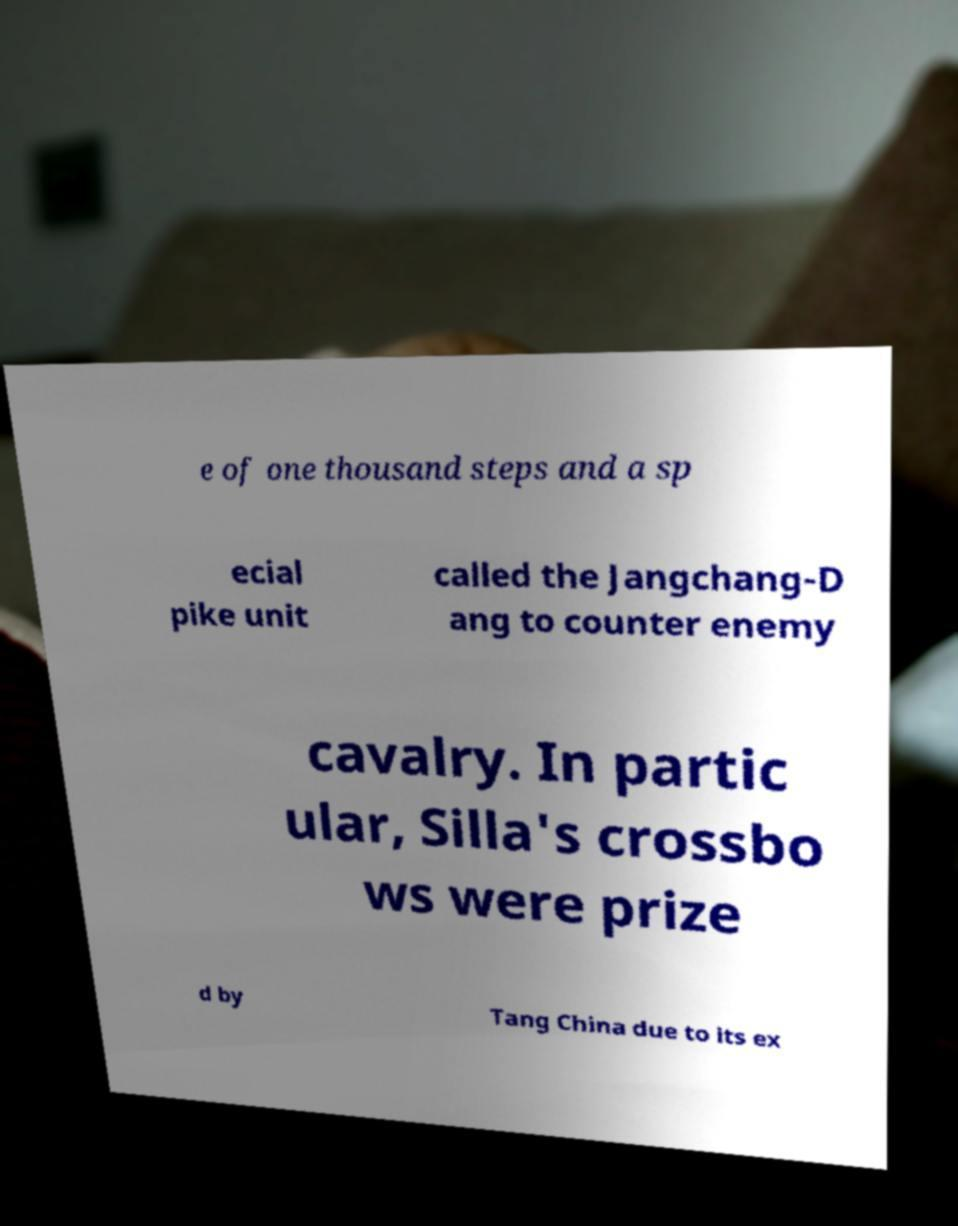What messages or text are displayed in this image? I need them in a readable, typed format. e of one thousand steps and a sp ecial pike unit called the Jangchang-D ang to counter enemy cavalry. In partic ular, Silla's crossbo ws were prize d by Tang China due to its ex 